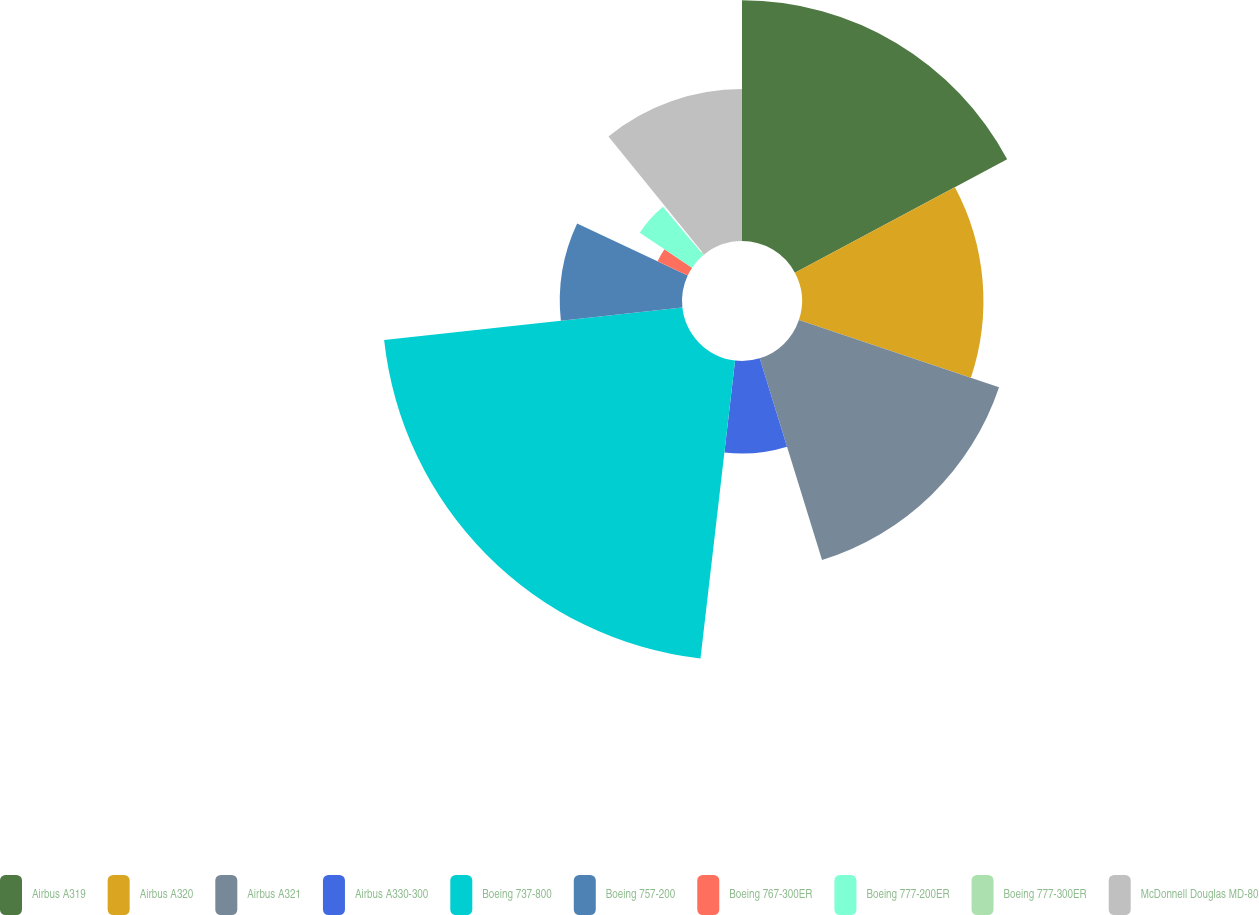Convert chart to OTSL. <chart><loc_0><loc_0><loc_500><loc_500><pie_chart><fcel>Airbus A319<fcel>Airbus A320<fcel>Airbus A321<fcel>Airbus A330-300<fcel>Boeing 737-800<fcel>Boeing 757-200<fcel>Boeing 767-300ER<fcel>Boeing 777-200ER<fcel>Boeing 777-300ER<fcel>McDonnell Douglas MD-80<nl><fcel>17.19%<fcel>12.96%<fcel>15.08%<fcel>6.61%<fcel>21.43%<fcel>8.73%<fcel>2.38%<fcel>4.5%<fcel>0.27%<fcel>10.85%<nl></chart> 